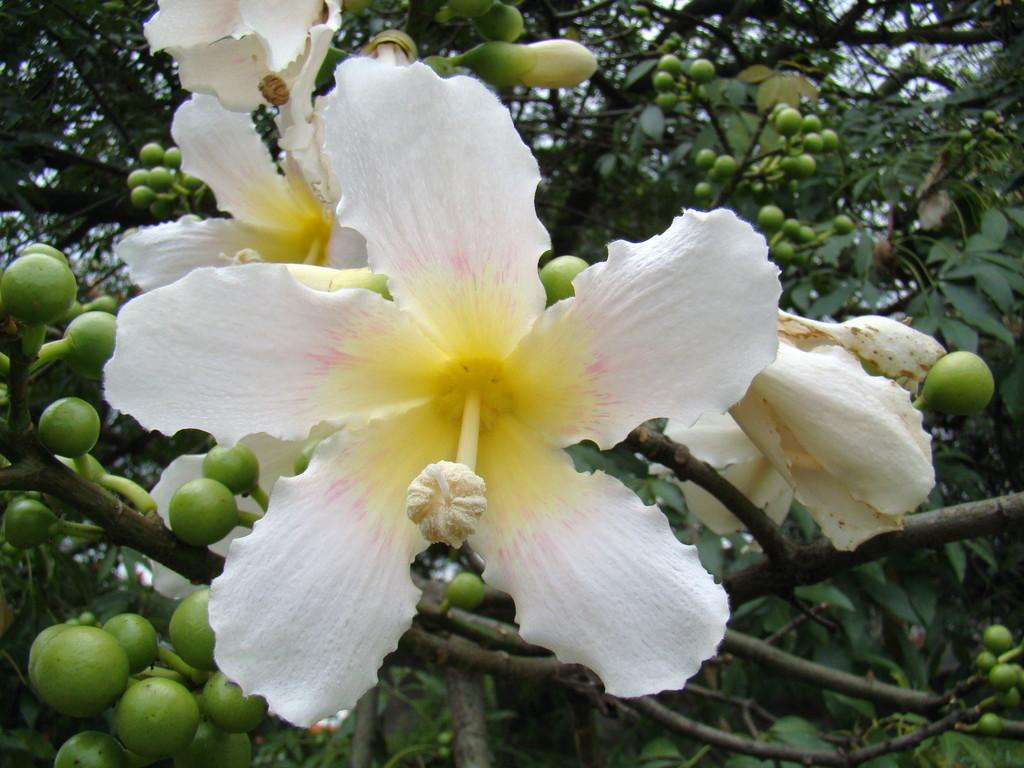What is the main subject in the middle of the image? There is a white flower in the middle of the image. Are there any other flowers or buds visible in the image? Yes, there are small buds beside the flower. What can be seen in the background of the image? There is a tree in the background of the image. How many volleyballs are hanging from the tree in the image? There are no volleyballs present in the image; it features a white flower, small buds, and a tree in the background. 